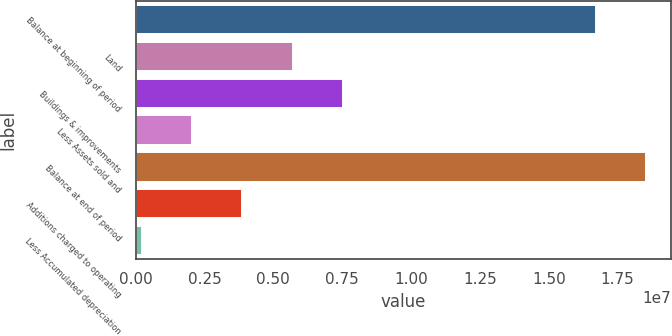Convert chart. <chart><loc_0><loc_0><loc_500><loc_500><bar_chart><fcel>Balance at beginning of period<fcel>Land<fcel>Buildings & improvements<fcel>Less Assets sold and<fcel>Balance at end of period<fcel>Additions charged to operating<fcel>Less Accumulated depreciation<nl><fcel>1.67038e+07<fcel>5.70575e+06<fcel>7.53284e+06<fcel>2.05158e+06<fcel>1.85308e+07<fcel>3.87866e+06<fcel>224489<nl></chart> 